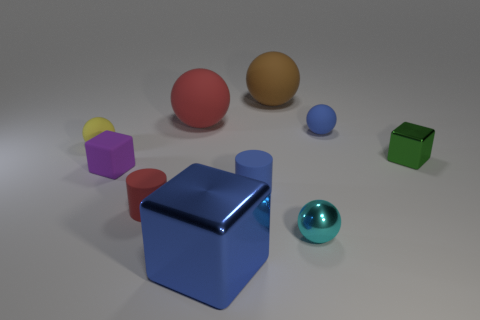Is the number of purple shiny things greater than the number of small purple rubber cubes? No, the number of purple shiny things is not greater. There is one large shiny purple sphere and one small purple rubber cube present, making the number equal. 